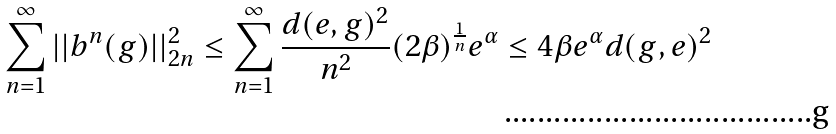Convert formula to latex. <formula><loc_0><loc_0><loc_500><loc_500>\sum ^ { \infty } _ { n = 1 } | | b ^ { n } ( g ) | | ^ { 2 } _ { 2 n } \leq \sum ^ { \infty } _ { n = 1 } \frac { d ( e , g ) ^ { 2 } } { n ^ { 2 } } ( 2 \beta ) ^ { \frac { 1 } { n } } e ^ { \alpha } \leq 4 \beta e ^ { \alpha } d ( g , e ) ^ { 2 }</formula> 